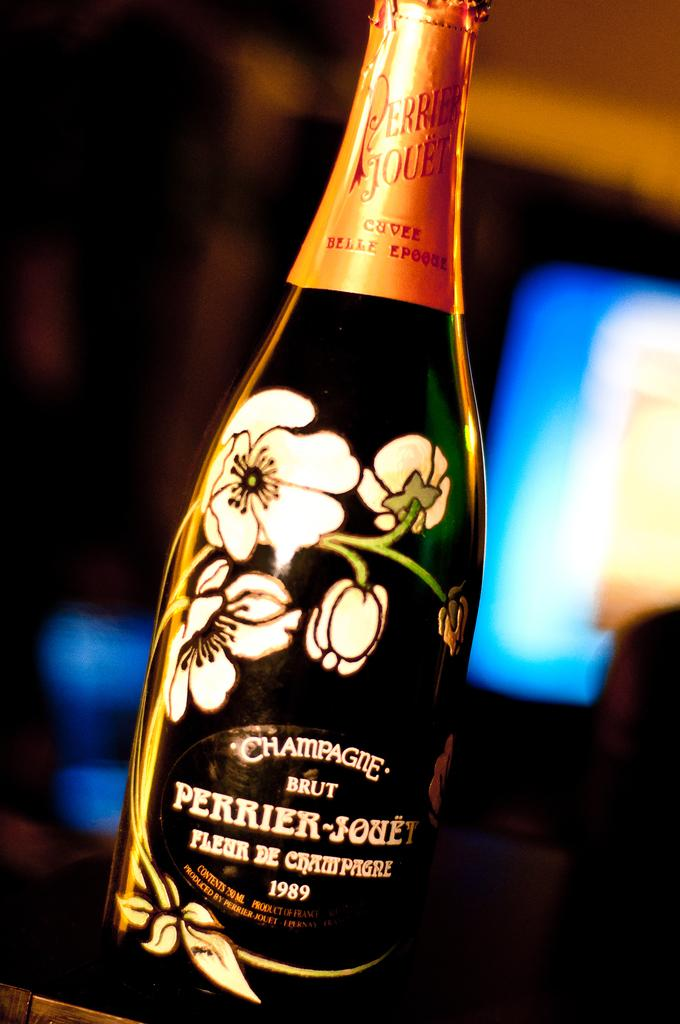<image>
Share a concise interpretation of the image provided. A bottle of champagne says "BRUT" on the label. 